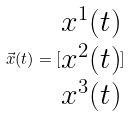Convert formula to latex. <formula><loc_0><loc_0><loc_500><loc_500>\vec { x } ( t ) = [ \begin{matrix} x ^ { 1 } ( t ) \\ x ^ { 2 } ( t ) \\ x ^ { 3 } ( t ) \end{matrix} ]</formula> 